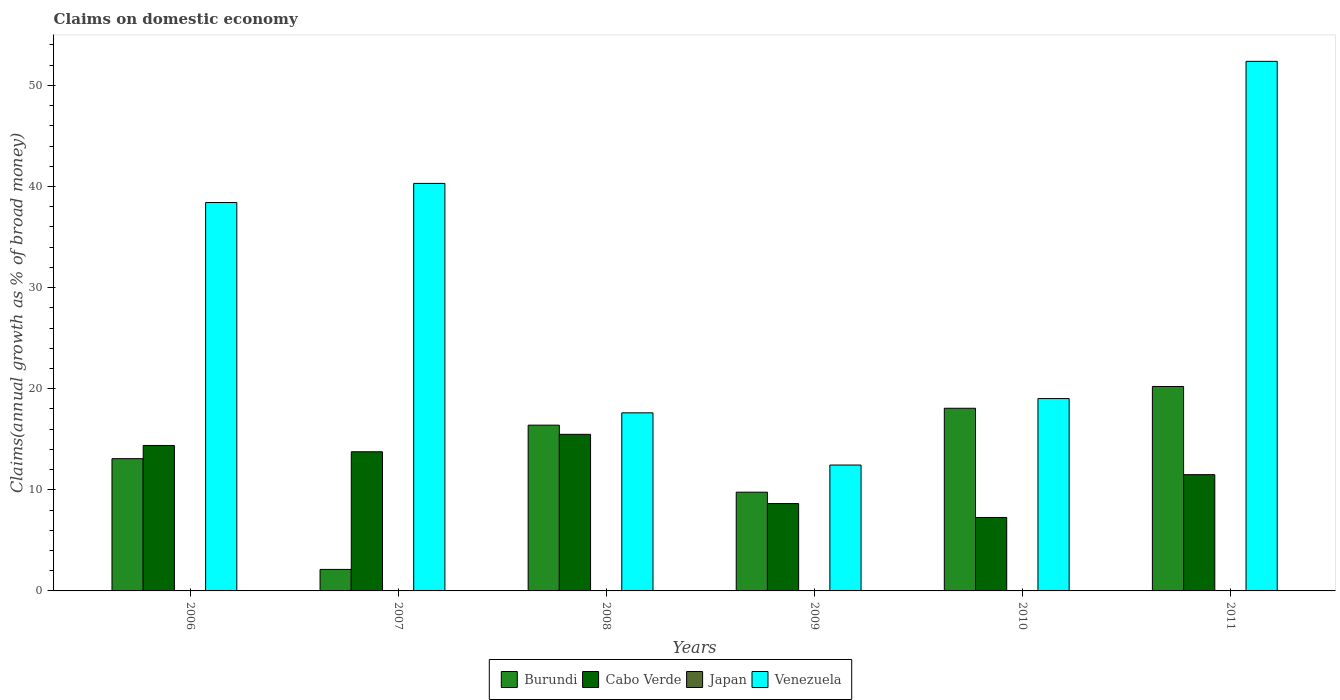How many different coloured bars are there?
Give a very brief answer. 3. Are the number of bars on each tick of the X-axis equal?
Offer a very short reply. Yes. How many bars are there on the 4th tick from the left?
Ensure brevity in your answer.  3. How many bars are there on the 3rd tick from the right?
Give a very brief answer. 3. What is the label of the 5th group of bars from the left?
Keep it short and to the point. 2010. In how many cases, is the number of bars for a given year not equal to the number of legend labels?
Provide a succinct answer. 6. Across all years, what is the maximum percentage of broad money claimed on domestic economy in Venezuela?
Offer a terse response. 52.38. Across all years, what is the minimum percentage of broad money claimed on domestic economy in Venezuela?
Your answer should be compact. 12.45. In which year was the percentage of broad money claimed on domestic economy in Venezuela maximum?
Your answer should be compact. 2011. What is the total percentage of broad money claimed on domestic economy in Cabo Verde in the graph?
Offer a very short reply. 71.04. What is the difference between the percentage of broad money claimed on domestic economy in Cabo Verde in 2006 and that in 2010?
Provide a short and direct response. 7.12. What is the difference between the percentage of broad money claimed on domestic economy in Cabo Verde in 2007 and the percentage of broad money claimed on domestic economy in Burundi in 2008?
Keep it short and to the point. -2.63. What is the average percentage of broad money claimed on domestic economy in Burundi per year?
Give a very brief answer. 13.28. In the year 2011, what is the difference between the percentage of broad money claimed on domestic economy in Cabo Verde and percentage of broad money claimed on domestic economy in Burundi?
Your answer should be very brief. -8.72. In how many years, is the percentage of broad money claimed on domestic economy in Japan greater than 12 %?
Ensure brevity in your answer.  0. What is the ratio of the percentage of broad money claimed on domestic economy in Cabo Verde in 2006 to that in 2009?
Keep it short and to the point. 1.67. What is the difference between the highest and the second highest percentage of broad money claimed on domestic economy in Burundi?
Your response must be concise. 2.15. What is the difference between the highest and the lowest percentage of broad money claimed on domestic economy in Cabo Verde?
Offer a terse response. 8.22. In how many years, is the percentage of broad money claimed on domestic economy in Cabo Verde greater than the average percentage of broad money claimed on domestic economy in Cabo Verde taken over all years?
Provide a short and direct response. 3. Is the sum of the percentage of broad money claimed on domestic economy in Cabo Verde in 2006 and 2010 greater than the maximum percentage of broad money claimed on domestic economy in Burundi across all years?
Ensure brevity in your answer.  Yes. Is it the case that in every year, the sum of the percentage of broad money claimed on domestic economy in Japan and percentage of broad money claimed on domestic economy in Venezuela is greater than the percentage of broad money claimed on domestic economy in Burundi?
Give a very brief answer. Yes. Are all the bars in the graph horizontal?
Your answer should be very brief. No. Does the graph contain any zero values?
Give a very brief answer. Yes. Does the graph contain grids?
Ensure brevity in your answer.  No. How many legend labels are there?
Offer a very short reply. 4. What is the title of the graph?
Offer a very short reply. Claims on domestic economy. What is the label or title of the X-axis?
Ensure brevity in your answer.  Years. What is the label or title of the Y-axis?
Provide a succinct answer. Claims(annual growth as % of broad money). What is the Claims(annual growth as % of broad money) in Burundi in 2006?
Give a very brief answer. 13.08. What is the Claims(annual growth as % of broad money) of Cabo Verde in 2006?
Offer a terse response. 14.39. What is the Claims(annual growth as % of broad money) in Japan in 2006?
Ensure brevity in your answer.  0. What is the Claims(annual growth as % of broad money) of Venezuela in 2006?
Your answer should be very brief. 38.42. What is the Claims(annual growth as % of broad money) in Burundi in 2007?
Offer a very short reply. 2.13. What is the Claims(annual growth as % of broad money) of Cabo Verde in 2007?
Make the answer very short. 13.76. What is the Claims(annual growth as % of broad money) of Japan in 2007?
Your response must be concise. 0. What is the Claims(annual growth as % of broad money) in Venezuela in 2007?
Keep it short and to the point. 40.31. What is the Claims(annual growth as % of broad money) of Burundi in 2008?
Give a very brief answer. 16.4. What is the Claims(annual growth as % of broad money) in Cabo Verde in 2008?
Provide a succinct answer. 15.49. What is the Claims(annual growth as % of broad money) in Venezuela in 2008?
Your response must be concise. 17.61. What is the Claims(annual growth as % of broad money) of Burundi in 2009?
Offer a terse response. 9.77. What is the Claims(annual growth as % of broad money) of Cabo Verde in 2009?
Ensure brevity in your answer.  8.64. What is the Claims(annual growth as % of broad money) in Japan in 2009?
Offer a terse response. 0. What is the Claims(annual growth as % of broad money) in Venezuela in 2009?
Ensure brevity in your answer.  12.45. What is the Claims(annual growth as % of broad money) in Burundi in 2010?
Offer a very short reply. 18.07. What is the Claims(annual growth as % of broad money) in Cabo Verde in 2010?
Offer a terse response. 7.26. What is the Claims(annual growth as % of broad money) of Venezuela in 2010?
Provide a short and direct response. 19.03. What is the Claims(annual growth as % of broad money) in Burundi in 2011?
Make the answer very short. 20.22. What is the Claims(annual growth as % of broad money) of Cabo Verde in 2011?
Your answer should be very brief. 11.5. What is the Claims(annual growth as % of broad money) of Venezuela in 2011?
Provide a short and direct response. 52.38. Across all years, what is the maximum Claims(annual growth as % of broad money) of Burundi?
Provide a succinct answer. 20.22. Across all years, what is the maximum Claims(annual growth as % of broad money) in Cabo Verde?
Your response must be concise. 15.49. Across all years, what is the maximum Claims(annual growth as % of broad money) of Venezuela?
Keep it short and to the point. 52.38. Across all years, what is the minimum Claims(annual growth as % of broad money) in Burundi?
Your answer should be compact. 2.13. Across all years, what is the minimum Claims(annual growth as % of broad money) in Cabo Verde?
Your response must be concise. 7.26. Across all years, what is the minimum Claims(annual growth as % of broad money) of Venezuela?
Provide a succinct answer. 12.45. What is the total Claims(annual growth as % of broad money) in Burundi in the graph?
Your answer should be very brief. 79.66. What is the total Claims(annual growth as % of broad money) of Cabo Verde in the graph?
Make the answer very short. 71.04. What is the total Claims(annual growth as % of broad money) in Japan in the graph?
Offer a very short reply. 0. What is the total Claims(annual growth as % of broad money) in Venezuela in the graph?
Your answer should be very brief. 180.19. What is the difference between the Claims(annual growth as % of broad money) in Burundi in 2006 and that in 2007?
Provide a succinct answer. 10.95. What is the difference between the Claims(annual growth as % of broad money) in Cabo Verde in 2006 and that in 2007?
Ensure brevity in your answer.  0.62. What is the difference between the Claims(annual growth as % of broad money) in Venezuela in 2006 and that in 2007?
Provide a short and direct response. -1.89. What is the difference between the Claims(annual growth as % of broad money) of Burundi in 2006 and that in 2008?
Make the answer very short. -3.31. What is the difference between the Claims(annual growth as % of broad money) in Cabo Verde in 2006 and that in 2008?
Offer a very short reply. -1.1. What is the difference between the Claims(annual growth as % of broad money) in Venezuela in 2006 and that in 2008?
Provide a short and direct response. 20.8. What is the difference between the Claims(annual growth as % of broad money) of Burundi in 2006 and that in 2009?
Offer a very short reply. 3.31. What is the difference between the Claims(annual growth as % of broad money) in Cabo Verde in 2006 and that in 2009?
Provide a short and direct response. 5.75. What is the difference between the Claims(annual growth as % of broad money) in Venezuela in 2006 and that in 2009?
Ensure brevity in your answer.  25.96. What is the difference between the Claims(annual growth as % of broad money) of Burundi in 2006 and that in 2010?
Keep it short and to the point. -4.99. What is the difference between the Claims(annual growth as % of broad money) in Cabo Verde in 2006 and that in 2010?
Offer a terse response. 7.12. What is the difference between the Claims(annual growth as % of broad money) of Venezuela in 2006 and that in 2010?
Give a very brief answer. 19.39. What is the difference between the Claims(annual growth as % of broad money) in Burundi in 2006 and that in 2011?
Keep it short and to the point. -7.14. What is the difference between the Claims(annual growth as % of broad money) in Cabo Verde in 2006 and that in 2011?
Provide a succinct answer. 2.89. What is the difference between the Claims(annual growth as % of broad money) of Venezuela in 2006 and that in 2011?
Your answer should be very brief. -13.96. What is the difference between the Claims(annual growth as % of broad money) in Burundi in 2007 and that in 2008?
Offer a very short reply. -14.27. What is the difference between the Claims(annual growth as % of broad money) in Cabo Verde in 2007 and that in 2008?
Offer a terse response. -1.72. What is the difference between the Claims(annual growth as % of broad money) of Venezuela in 2007 and that in 2008?
Provide a succinct answer. 22.69. What is the difference between the Claims(annual growth as % of broad money) in Burundi in 2007 and that in 2009?
Make the answer very short. -7.64. What is the difference between the Claims(annual growth as % of broad money) of Cabo Verde in 2007 and that in 2009?
Offer a terse response. 5.12. What is the difference between the Claims(annual growth as % of broad money) of Venezuela in 2007 and that in 2009?
Your response must be concise. 27.86. What is the difference between the Claims(annual growth as % of broad money) in Burundi in 2007 and that in 2010?
Your answer should be compact. -15.94. What is the difference between the Claims(annual growth as % of broad money) of Cabo Verde in 2007 and that in 2010?
Offer a very short reply. 6.5. What is the difference between the Claims(annual growth as % of broad money) of Venezuela in 2007 and that in 2010?
Your answer should be compact. 21.28. What is the difference between the Claims(annual growth as % of broad money) in Burundi in 2007 and that in 2011?
Provide a succinct answer. -18.09. What is the difference between the Claims(annual growth as % of broad money) in Cabo Verde in 2007 and that in 2011?
Offer a very short reply. 2.26. What is the difference between the Claims(annual growth as % of broad money) of Venezuela in 2007 and that in 2011?
Your response must be concise. -12.07. What is the difference between the Claims(annual growth as % of broad money) of Burundi in 2008 and that in 2009?
Provide a short and direct response. 6.63. What is the difference between the Claims(annual growth as % of broad money) in Cabo Verde in 2008 and that in 2009?
Make the answer very short. 6.85. What is the difference between the Claims(annual growth as % of broad money) of Venezuela in 2008 and that in 2009?
Your response must be concise. 5.16. What is the difference between the Claims(annual growth as % of broad money) of Burundi in 2008 and that in 2010?
Offer a very short reply. -1.67. What is the difference between the Claims(annual growth as % of broad money) in Cabo Verde in 2008 and that in 2010?
Provide a short and direct response. 8.22. What is the difference between the Claims(annual growth as % of broad money) of Venezuela in 2008 and that in 2010?
Your response must be concise. -1.41. What is the difference between the Claims(annual growth as % of broad money) in Burundi in 2008 and that in 2011?
Your answer should be very brief. -3.82. What is the difference between the Claims(annual growth as % of broad money) of Cabo Verde in 2008 and that in 2011?
Your answer should be compact. 3.99. What is the difference between the Claims(annual growth as % of broad money) in Venezuela in 2008 and that in 2011?
Your answer should be compact. -34.77. What is the difference between the Claims(annual growth as % of broad money) of Burundi in 2009 and that in 2010?
Offer a very short reply. -8.3. What is the difference between the Claims(annual growth as % of broad money) of Cabo Verde in 2009 and that in 2010?
Your answer should be compact. 1.37. What is the difference between the Claims(annual growth as % of broad money) of Venezuela in 2009 and that in 2010?
Provide a short and direct response. -6.57. What is the difference between the Claims(annual growth as % of broad money) in Burundi in 2009 and that in 2011?
Provide a succinct answer. -10.45. What is the difference between the Claims(annual growth as % of broad money) of Cabo Verde in 2009 and that in 2011?
Give a very brief answer. -2.86. What is the difference between the Claims(annual growth as % of broad money) of Venezuela in 2009 and that in 2011?
Your response must be concise. -39.93. What is the difference between the Claims(annual growth as % of broad money) in Burundi in 2010 and that in 2011?
Provide a succinct answer. -2.15. What is the difference between the Claims(annual growth as % of broad money) in Cabo Verde in 2010 and that in 2011?
Ensure brevity in your answer.  -4.24. What is the difference between the Claims(annual growth as % of broad money) of Venezuela in 2010 and that in 2011?
Offer a very short reply. -33.35. What is the difference between the Claims(annual growth as % of broad money) in Burundi in 2006 and the Claims(annual growth as % of broad money) in Cabo Verde in 2007?
Provide a succinct answer. -0.68. What is the difference between the Claims(annual growth as % of broad money) in Burundi in 2006 and the Claims(annual growth as % of broad money) in Venezuela in 2007?
Provide a short and direct response. -27.23. What is the difference between the Claims(annual growth as % of broad money) of Cabo Verde in 2006 and the Claims(annual growth as % of broad money) of Venezuela in 2007?
Ensure brevity in your answer.  -25.92. What is the difference between the Claims(annual growth as % of broad money) in Burundi in 2006 and the Claims(annual growth as % of broad money) in Cabo Verde in 2008?
Keep it short and to the point. -2.41. What is the difference between the Claims(annual growth as % of broad money) in Burundi in 2006 and the Claims(annual growth as % of broad money) in Venezuela in 2008?
Give a very brief answer. -4.53. What is the difference between the Claims(annual growth as % of broad money) of Cabo Verde in 2006 and the Claims(annual growth as % of broad money) of Venezuela in 2008?
Give a very brief answer. -3.23. What is the difference between the Claims(annual growth as % of broad money) in Burundi in 2006 and the Claims(annual growth as % of broad money) in Cabo Verde in 2009?
Make the answer very short. 4.44. What is the difference between the Claims(annual growth as % of broad money) of Burundi in 2006 and the Claims(annual growth as % of broad money) of Venezuela in 2009?
Your answer should be very brief. 0.63. What is the difference between the Claims(annual growth as % of broad money) of Cabo Verde in 2006 and the Claims(annual growth as % of broad money) of Venezuela in 2009?
Provide a succinct answer. 1.94. What is the difference between the Claims(annual growth as % of broad money) in Burundi in 2006 and the Claims(annual growth as % of broad money) in Cabo Verde in 2010?
Give a very brief answer. 5.82. What is the difference between the Claims(annual growth as % of broad money) of Burundi in 2006 and the Claims(annual growth as % of broad money) of Venezuela in 2010?
Offer a very short reply. -5.94. What is the difference between the Claims(annual growth as % of broad money) in Cabo Verde in 2006 and the Claims(annual growth as % of broad money) in Venezuela in 2010?
Keep it short and to the point. -4.64. What is the difference between the Claims(annual growth as % of broad money) of Burundi in 2006 and the Claims(annual growth as % of broad money) of Cabo Verde in 2011?
Your answer should be very brief. 1.58. What is the difference between the Claims(annual growth as % of broad money) in Burundi in 2006 and the Claims(annual growth as % of broad money) in Venezuela in 2011?
Your answer should be compact. -39.3. What is the difference between the Claims(annual growth as % of broad money) in Cabo Verde in 2006 and the Claims(annual growth as % of broad money) in Venezuela in 2011?
Make the answer very short. -37.99. What is the difference between the Claims(annual growth as % of broad money) in Burundi in 2007 and the Claims(annual growth as % of broad money) in Cabo Verde in 2008?
Give a very brief answer. -13.36. What is the difference between the Claims(annual growth as % of broad money) of Burundi in 2007 and the Claims(annual growth as % of broad money) of Venezuela in 2008?
Your answer should be very brief. -15.49. What is the difference between the Claims(annual growth as % of broad money) of Cabo Verde in 2007 and the Claims(annual growth as % of broad money) of Venezuela in 2008?
Ensure brevity in your answer.  -3.85. What is the difference between the Claims(annual growth as % of broad money) in Burundi in 2007 and the Claims(annual growth as % of broad money) in Cabo Verde in 2009?
Provide a succinct answer. -6.51. What is the difference between the Claims(annual growth as % of broad money) of Burundi in 2007 and the Claims(annual growth as % of broad money) of Venezuela in 2009?
Make the answer very short. -10.32. What is the difference between the Claims(annual growth as % of broad money) in Cabo Verde in 2007 and the Claims(annual growth as % of broad money) in Venezuela in 2009?
Keep it short and to the point. 1.31. What is the difference between the Claims(annual growth as % of broad money) in Burundi in 2007 and the Claims(annual growth as % of broad money) in Cabo Verde in 2010?
Make the answer very short. -5.14. What is the difference between the Claims(annual growth as % of broad money) in Burundi in 2007 and the Claims(annual growth as % of broad money) in Venezuela in 2010?
Your answer should be compact. -16.9. What is the difference between the Claims(annual growth as % of broad money) of Cabo Verde in 2007 and the Claims(annual growth as % of broad money) of Venezuela in 2010?
Offer a very short reply. -5.26. What is the difference between the Claims(annual growth as % of broad money) in Burundi in 2007 and the Claims(annual growth as % of broad money) in Cabo Verde in 2011?
Ensure brevity in your answer.  -9.37. What is the difference between the Claims(annual growth as % of broad money) of Burundi in 2007 and the Claims(annual growth as % of broad money) of Venezuela in 2011?
Offer a very short reply. -50.25. What is the difference between the Claims(annual growth as % of broad money) in Cabo Verde in 2007 and the Claims(annual growth as % of broad money) in Venezuela in 2011?
Offer a terse response. -38.62. What is the difference between the Claims(annual growth as % of broad money) in Burundi in 2008 and the Claims(annual growth as % of broad money) in Cabo Verde in 2009?
Offer a terse response. 7.76. What is the difference between the Claims(annual growth as % of broad money) in Burundi in 2008 and the Claims(annual growth as % of broad money) in Venezuela in 2009?
Offer a terse response. 3.94. What is the difference between the Claims(annual growth as % of broad money) of Cabo Verde in 2008 and the Claims(annual growth as % of broad money) of Venezuela in 2009?
Make the answer very short. 3.04. What is the difference between the Claims(annual growth as % of broad money) of Burundi in 2008 and the Claims(annual growth as % of broad money) of Cabo Verde in 2010?
Your answer should be compact. 9.13. What is the difference between the Claims(annual growth as % of broad money) of Burundi in 2008 and the Claims(annual growth as % of broad money) of Venezuela in 2010?
Your response must be concise. -2.63. What is the difference between the Claims(annual growth as % of broad money) in Cabo Verde in 2008 and the Claims(annual growth as % of broad money) in Venezuela in 2010?
Offer a very short reply. -3.54. What is the difference between the Claims(annual growth as % of broad money) of Burundi in 2008 and the Claims(annual growth as % of broad money) of Cabo Verde in 2011?
Keep it short and to the point. 4.9. What is the difference between the Claims(annual growth as % of broad money) in Burundi in 2008 and the Claims(annual growth as % of broad money) in Venezuela in 2011?
Offer a very short reply. -35.98. What is the difference between the Claims(annual growth as % of broad money) in Cabo Verde in 2008 and the Claims(annual growth as % of broad money) in Venezuela in 2011?
Provide a short and direct response. -36.89. What is the difference between the Claims(annual growth as % of broad money) in Burundi in 2009 and the Claims(annual growth as % of broad money) in Cabo Verde in 2010?
Give a very brief answer. 2.5. What is the difference between the Claims(annual growth as % of broad money) in Burundi in 2009 and the Claims(annual growth as % of broad money) in Venezuela in 2010?
Offer a very short reply. -9.26. What is the difference between the Claims(annual growth as % of broad money) in Cabo Verde in 2009 and the Claims(annual growth as % of broad money) in Venezuela in 2010?
Your response must be concise. -10.39. What is the difference between the Claims(annual growth as % of broad money) in Burundi in 2009 and the Claims(annual growth as % of broad money) in Cabo Verde in 2011?
Keep it short and to the point. -1.73. What is the difference between the Claims(annual growth as % of broad money) of Burundi in 2009 and the Claims(annual growth as % of broad money) of Venezuela in 2011?
Your answer should be very brief. -42.61. What is the difference between the Claims(annual growth as % of broad money) in Cabo Verde in 2009 and the Claims(annual growth as % of broad money) in Venezuela in 2011?
Your response must be concise. -43.74. What is the difference between the Claims(annual growth as % of broad money) of Burundi in 2010 and the Claims(annual growth as % of broad money) of Cabo Verde in 2011?
Give a very brief answer. 6.57. What is the difference between the Claims(annual growth as % of broad money) of Burundi in 2010 and the Claims(annual growth as % of broad money) of Venezuela in 2011?
Provide a short and direct response. -34.31. What is the difference between the Claims(annual growth as % of broad money) in Cabo Verde in 2010 and the Claims(annual growth as % of broad money) in Venezuela in 2011?
Give a very brief answer. -45.11. What is the average Claims(annual growth as % of broad money) in Burundi per year?
Offer a terse response. 13.28. What is the average Claims(annual growth as % of broad money) of Cabo Verde per year?
Your response must be concise. 11.84. What is the average Claims(annual growth as % of broad money) in Japan per year?
Your answer should be compact. 0. What is the average Claims(annual growth as % of broad money) in Venezuela per year?
Make the answer very short. 30.03. In the year 2006, what is the difference between the Claims(annual growth as % of broad money) in Burundi and Claims(annual growth as % of broad money) in Cabo Verde?
Offer a very short reply. -1.31. In the year 2006, what is the difference between the Claims(annual growth as % of broad money) of Burundi and Claims(annual growth as % of broad money) of Venezuela?
Your response must be concise. -25.33. In the year 2006, what is the difference between the Claims(annual growth as % of broad money) in Cabo Verde and Claims(annual growth as % of broad money) in Venezuela?
Your response must be concise. -24.03. In the year 2007, what is the difference between the Claims(annual growth as % of broad money) of Burundi and Claims(annual growth as % of broad money) of Cabo Verde?
Offer a terse response. -11.64. In the year 2007, what is the difference between the Claims(annual growth as % of broad money) of Burundi and Claims(annual growth as % of broad money) of Venezuela?
Your answer should be very brief. -38.18. In the year 2007, what is the difference between the Claims(annual growth as % of broad money) of Cabo Verde and Claims(annual growth as % of broad money) of Venezuela?
Offer a very short reply. -26.55. In the year 2008, what is the difference between the Claims(annual growth as % of broad money) of Burundi and Claims(annual growth as % of broad money) of Cabo Verde?
Your answer should be compact. 0.91. In the year 2008, what is the difference between the Claims(annual growth as % of broad money) of Burundi and Claims(annual growth as % of broad money) of Venezuela?
Give a very brief answer. -1.22. In the year 2008, what is the difference between the Claims(annual growth as % of broad money) of Cabo Verde and Claims(annual growth as % of broad money) of Venezuela?
Your answer should be very brief. -2.13. In the year 2009, what is the difference between the Claims(annual growth as % of broad money) in Burundi and Claims(annual growth as % of broad money) in Cabo Verde?
Your answer should be very brief. 1.13. In the year 2009, what is the difference between the Claims(annual growth as % of broad money) in Burundi and Claims(annual growth as % of broad money) in Venezuela?
Your answer should be compact. -2.68. In the year 2009, what is the difference between the Claims(annual growth as % of broad money) of Cabo Verde and Claims(annual growth as % of broad money) of Venezuela?
Your answer should be compact. -3.81. In the year 2010, what is the difference between the Claims(annual growth as % of broad money) of Burundi and Claims(annual growth as % of broad money) of Cabo Verde?
Offer a terse response. 10.8. In the year 2010, what is the difference between the Claims(annual growth as % of broad money) in Burundi and Claims(annual growth as % of broad money) in Venezuela?
Provide a short and direct response. -0.96. In the year 2010, what is the difference between the Claims(annual growth as % of broad money) of Cabo Verde and Claims(annual growth as % of broad money) of Venezuela?
Provide a succinct answer. -11.76. In the year 2011, what is the difference between the Claims(annual growth as % of broad money) of Burundi and Claims(annual growth as % of broad money) of Cabo Verde?
Give a very brief answer. 8.72. In the year 2011, what is the difference between the Claims(annual growth as % of broad money) in Burundi and Claims(annual growth as % of broad money) in Venezuela?
Your response must be concise. -32.16. In the year 2011, what is the difference between the Claims(annual growth as % of broad money) of Cabo Verde and Claims(annual growth as % of broad money) of Venezuela?
Make the answer very short. -40.88. What is the ratio of the Claims(annual growth as % of broad money) in Burundi in 2006 to that in 2007?
Keep it short and to the point. 6.15. What is the ratio of the Claims(annual growth as % of broad money) of Cabo Verde in 2006 to that in 2007?
Provide a short and direct response. 1.05. What is the ratio of the Claims(annual growth as % of broad money) of Venezuela in 2006 to that in 2007?
Make the answer very short. 0.95. What is the ratio of the Claims(annual growth as % of broad money) of Burundi in 2006 to that in 2008?
Your answer should be very brief. 0.8. What is the ratio of the Claims(annual growth as % of broad money) of Cabo Verde in 2006 to that in 2008?
Your answer should be compact. 0.93. What is the ratio of the Claims(annual growth as % of broad money) in Venezuela in 2006 to that in 2008?
Ensure brevity in your answer.  2.18. What is the ratio of the Claims(annual growth as % of broad money) in Burundi in 2006 to that in 2009?
Provide a short and direct response. 1.34. What is the ratio of the Claims(annual growth as % of broad money) in Cabo Verde in 2006 to that in 2009?
Your answer should be compact. 1.67. What is the ratio of the Claims(annual growth as % of broad money) of Venezuela in 2006 to that in 2009?
Your answer should be compact. 3.09. What is the ratio of the Claims(annual growth as % of broad money) of Burundi in 2006 to that in 2010?
Provide a succinct answer. 0.72. What is the ratio of the Claims(annual growth as % of broad money) of Cabo Verde in 2006 to that in 2010?
Your answer should be very brief. 1.98. What is the ratio of the Claims(annual growth as % of broad money) in Venezuela in 2006 to that in 2010?
Provide a succinct answer. 2.02. What is the ratio of the Claims(annual growth as % of broad money) of Burundi in 2006 to that in 2011?
Your response must be concise. 0.65. What is the ratio of the Claims(annual growth as % of broad money) in Cabo Verde in 2006 to that in 2011?
Provide a succinct answer. 1.25. What is the ratio of the Claims(annual growth as % of broad money) of Venezuela in 2006 to that in 2011?
Offer a very short reply. 0.73. What is the ratio of the Claims(annual growth as % of broad money) in Burundi in 2007 to that in 2008?
Offer a very short reply. 0.13. What is the ratio of the Claims(annual growth as % of broad money) in Cabo Verde in 2007 to that in 2008?
Provide a short and direct response. 0.89. What is the ratio of the Claims(annual growth as % of broad money) in Venezuela in 2007 to that in 2008?
Your answer should be compact. 2.29. What is the ratio of the Claims(annual growth as % of broad money) in Burundi in 2007 to that in 2009?
Offer a very short reply. 0.22. What is the ratio of the Claims(annual growth as % of broad money) of Cabo Verde in 2007 to that in 2009?
Keep it short and to the point. 1.59. What is the ratio of the Claims(annual growth as % of broad money) in Venezuela in 2007 to that in 2009?
Your answer should be very brief. 3.24. What is the ratio of the Claims(annual growth as % of broad money) of Burundi in 2007 to that in 2010?
Provide a succinct answer. 0.12. What is the ratio of the Claims(annual growth as % of broad money) in Cabo Verde in 2007 to that in 2010?
Ensure brevity in your answer.  1.89. What is the ratio of the Claims(annual growth as % of broad money) in Venezuela in 2007 to that in 2010?
Ensure brevity in your answer.  2.12. What is the ratio of the Claims(annual growth as % of broad money) of Burundi in 2007 to that in 2011?
Ensure brevity in your answer.  0.11. What is the ratio of the Claims(annual growth as % of broad money) in Cabo Verde in 2007 to that in 2011?
Your response must be concise. 1.2. What is the ratio of the Claims(annual growth as % of broad money) of Venezuela in 2007 to that in 2011?
Ensure brevity in your answer.  0.77. What is the ratio of the Claims(annual growth as % of broad money) in Burundi in 2008 to that in 2009?
Make the answer very short. 1.68. What is the ratio of the Claims(annual growth as % of broad money) in Cabo Verde in 2008 to that in 2009?
Offer a terse response. 1.79. What is the ratio of the Claims(annual growth as % of broad money) in Venezuela in 2008 to that in 2009?
Ensure brevity in your answer.  1.41. What is the ratio of the Claims(annual growth as % of broad money) of Burundi in 2008 to that in 2010?
Your answer should be compact. 0.91. What is the ratio of the Claims(annual growth as % of broad money) of Cabo Verde in 2008 to that in 2010?
Your answer should be compact. 2.13. What is the ratio of the Claims(annual growth as % of broad money) of Venezuela in 2008 to that in 2010?
Your answer should be very brief. 0.93. What is the ratio of the Claims(annual growth as % of broad money) in Burundi in 2008 to that in 2011?
Keep it short and to the point. 0.81. What is the ratio of the Claims(annual growth as % of broad money) in Cabo Verde in 2008 to that in 2011?
Give a very brief answer. 1.35. What is the ratio of the Claims(annual growth as % of broad money) of Venezuela in 2008 to that in 2011?
Make the answer very short. 0.34. What is the ratio of the Claims(annual growth as % of broad money) in Burundi in 2009 to that in 2010?
Keep it short and to the point. 0.54. What is the ratio of the Claims(annual growth as % of broad money) in Cabo Verde in 2009 to that in 2010?
Your answer should be very brief. 1.19. What is the ratio of the Claims(annual growth as % of broad money) of Venezuela in 2009 to that in 2010?
Your response must be concise. 0.65. What is the ratio of the Claims(annual growth as % of broad money) in Burundi in 2009 to that in 2011?
Keep it short and to the point. 0.48. What is the ratio of the Claims(annual growth as % of broad money) of Cabo Verde in 2009 to that in 2011?
Keep it short and to the point. 0.75. What is the ratio of the Claims(annual growth as % of broad money) of Venezuela in 2009 to that in 2011?
Offer a very short reply. 0.24. What is the ratio of the Claims(annual growth as % of broad money) in Burundi in 2010 to that in 2011?
Offer a terse response. 0.89. What is the ratio of the Claims(annual growth as % of broad money) in Cabo Verde in 2010 to that in 2011?
Give a very brief answer. 0.63. What is the ratio of the Claims(annual growth as % of broad money) of Venezuela in 2010 to that in 2011?
Your answer should be compact. 0.36. What is the difference between the highest and the second highest Claims(annual growth as % of broad money) of Burundi?
Make the answer very short. 2.15. What is the difference between the highest and the second highest Claims(annual growth as % of broad money) in Cabo Verde?
Provide a succinct answer. 1.1. What is the difference between the highest and the second highest Claims(annual growth as % of broad money) in Venezuela?
Your response must be concise. 12.07. What is the difference between the highest and the lowest Claims(annual growth as % of broad money) of Burundi?
Your response must be concise. 18.09. What is the difference between the highest and the lowest Claims(annual growth as % of broad money) of Cabo Verde?
Offer a terse response. 8.22. What is the difference between the highest and the lowest Claims(annual growth as % of broad money) in Venezuela?
Make the answer very short. 39.93. 